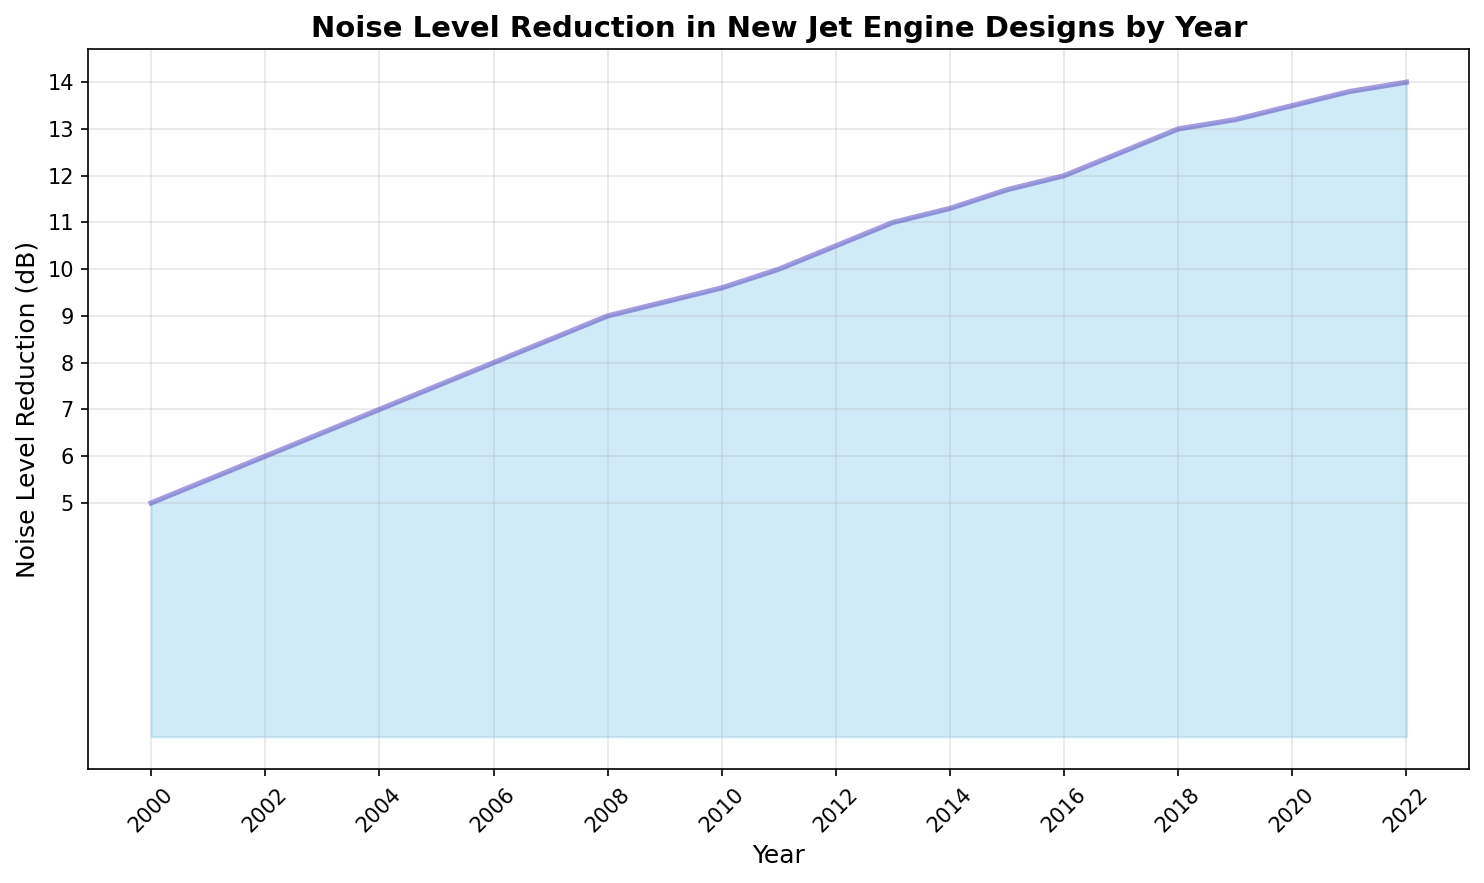What is the noise level reduction in 2010? To find the noise level reduction in 2010, refer to the value for the year 2010 on the y-axis of the figure.
Answer: 9.6 dB What is the difference in noise level reduction between 2000 and 2022? Subtract the noise level reduction value in 2000 from the value in 2022: 14 dB - 5 dB = 9 dB.
Answer: 9 dB In which year did the noise level reduction reach 10 dB? Find the year on the x-axis where the noise level reduction on the y-axis is 10 dB.
Answer: 2011 Which year had a greater noise level reduction: 2015 or 2018? Compare the noise level reduction values for the years 2015 and 2018: 11.7 dB in 2015 and 13 dB in 2018.
Answer: 2018 What was the average noise level reduction from 2000 to 2005? Calculate the average of the noise level reductions from 2000 to 2005: (5 + 5.5 + 6 + 6.5 + 7 + 7.5) / 6 = 6.25 dB.
Answer: 6.25 dB How does the slope of the line change between 2009 and 2011? Observe the steepness of the line between 2009 and 2011. The slope increases from a less steep to a steeper slope, indicating a faster rate of improvement in noise reduction.
Answer: Increases What was the percentage increase in noise level reduction from 2000 to 2022? Calculate the percentage increase: [(2022 value - 2000 value) / 2000 value] * 100 = [(14 - 5) / 5] * 100 = 180%.
Answer: 180% What is the median noise level reduction value from 2000 to 2022? Arrange the noise level reduction values in ascending order and find the middle value. The middle value between the 11th and 12th data points: (8.5 + 9) / 2 = 9.05 dB.
Answer: 9.05 dB What can be inferred about the overall trend in noise level reduction from 2000 to 2022? Observe the line and the filled area which indicates a consistent increase in noise level reduction over the years, suggesting continuous improvement in jet engine designs.
Answer: Consistent increase Which time period saw the largest increase in noise level reduction, 2000-2010 or 2011-2022? Calculate the increase for each period: 2000-2010: (9.6 - 5) = 4.6 dB, 2011-2022: (14 - 10) = 4 dB.
Answer: 2000-2010 